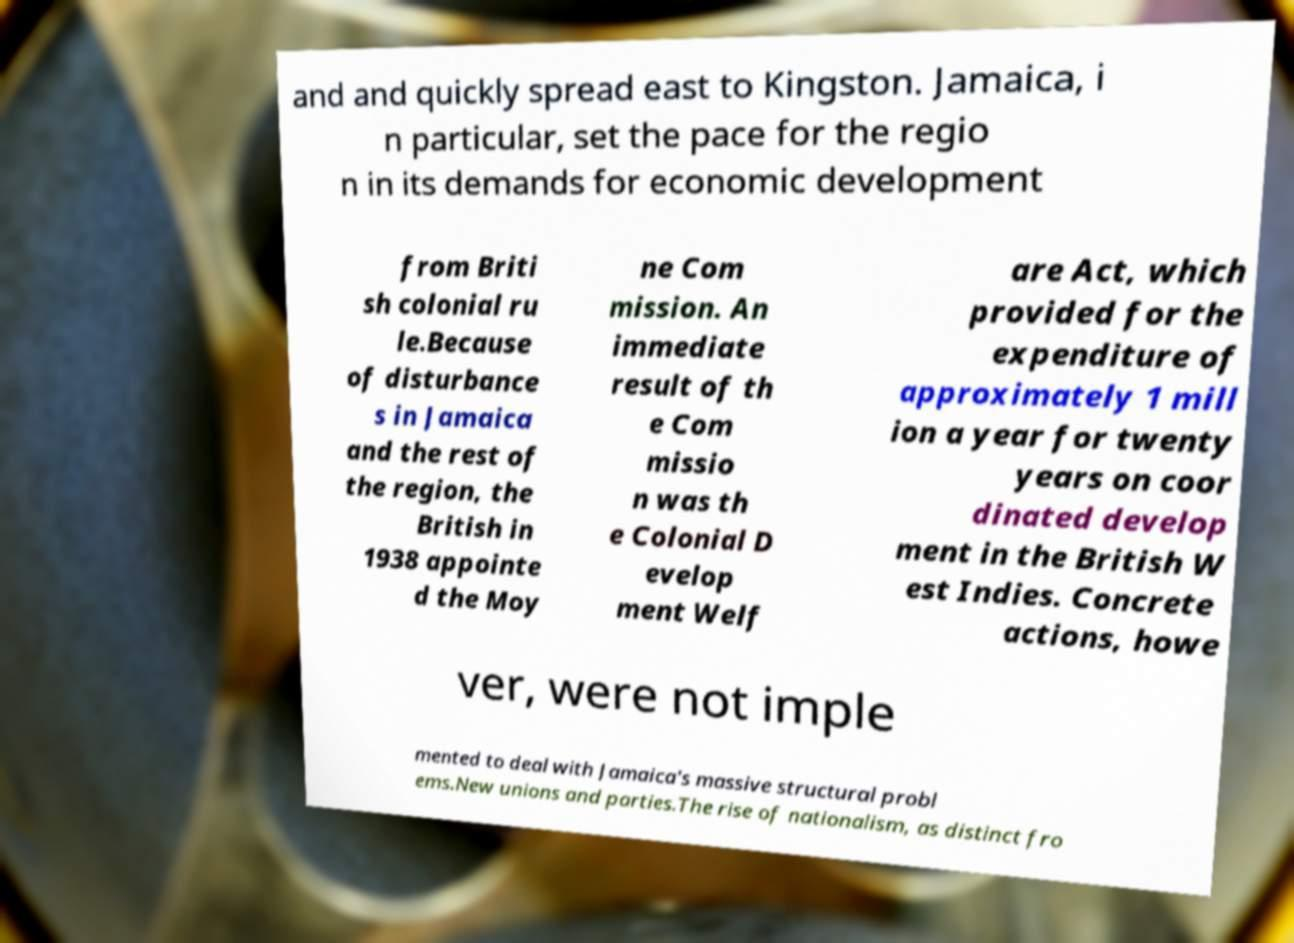Can you accurately transcribe the text from the provided image for me? and and quickly spread east to Kingston. Jamaica, i n particular, set the pace for the regio n in its demands for economic development from Briti sh colonial ru le.Because of disturbance s in Jamaica and the rest of the region, the British in 1938 appointe d the Moy ne Com mission. An immediate result of th e Com missio n was th e Colonial D evelop ment Welf are Act, which provided for the expenditure of approximately 1 mill ion a year for twenty years on coor dinated develop ment in the British W est Indies. Concrete actions, howe ver, were not imple mented to deal with Jamaica's massive structural probl ems.New unions and parties.The rise of nationalism, as distinct fro 